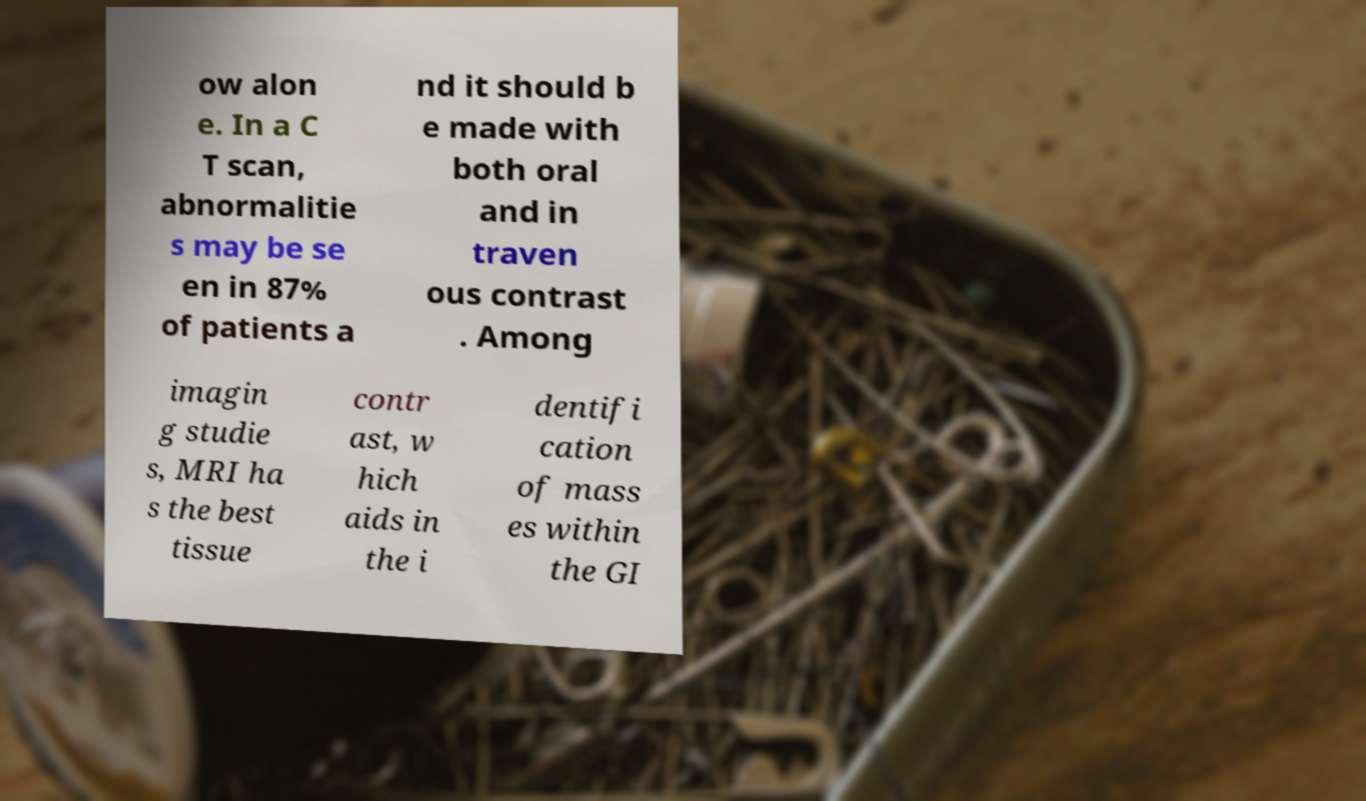Please read and relay the text visible in this image. What does it say? ow alon e. In a C T scan, abnormalitie s may be se en in 87% of patients a nd it should b e made with both oral and in traven ous contrast . Among imagin g studie s, MRI ha s the best tissue contr ast, w hich aids in the i dentifi cation of mass es within the GI 